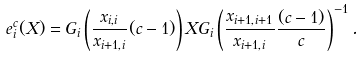Convert formula to latex. <formula><loc_0><loc_0><loc_500><loc_500>e _ { i } ^ { c } ( X ) = G _ { i } \left ( \frac { x _ { i , i } } { x _ { i + 1 , i } } ( c - 1 ) \right ) X G _ { i } \left ( \frac { x _ { i + 1 , i + 1 } } { x _ { i + 1 , i } } \frac { ( c - 1 ) } { c } \right ) ^ { - 1 } .</formula> 